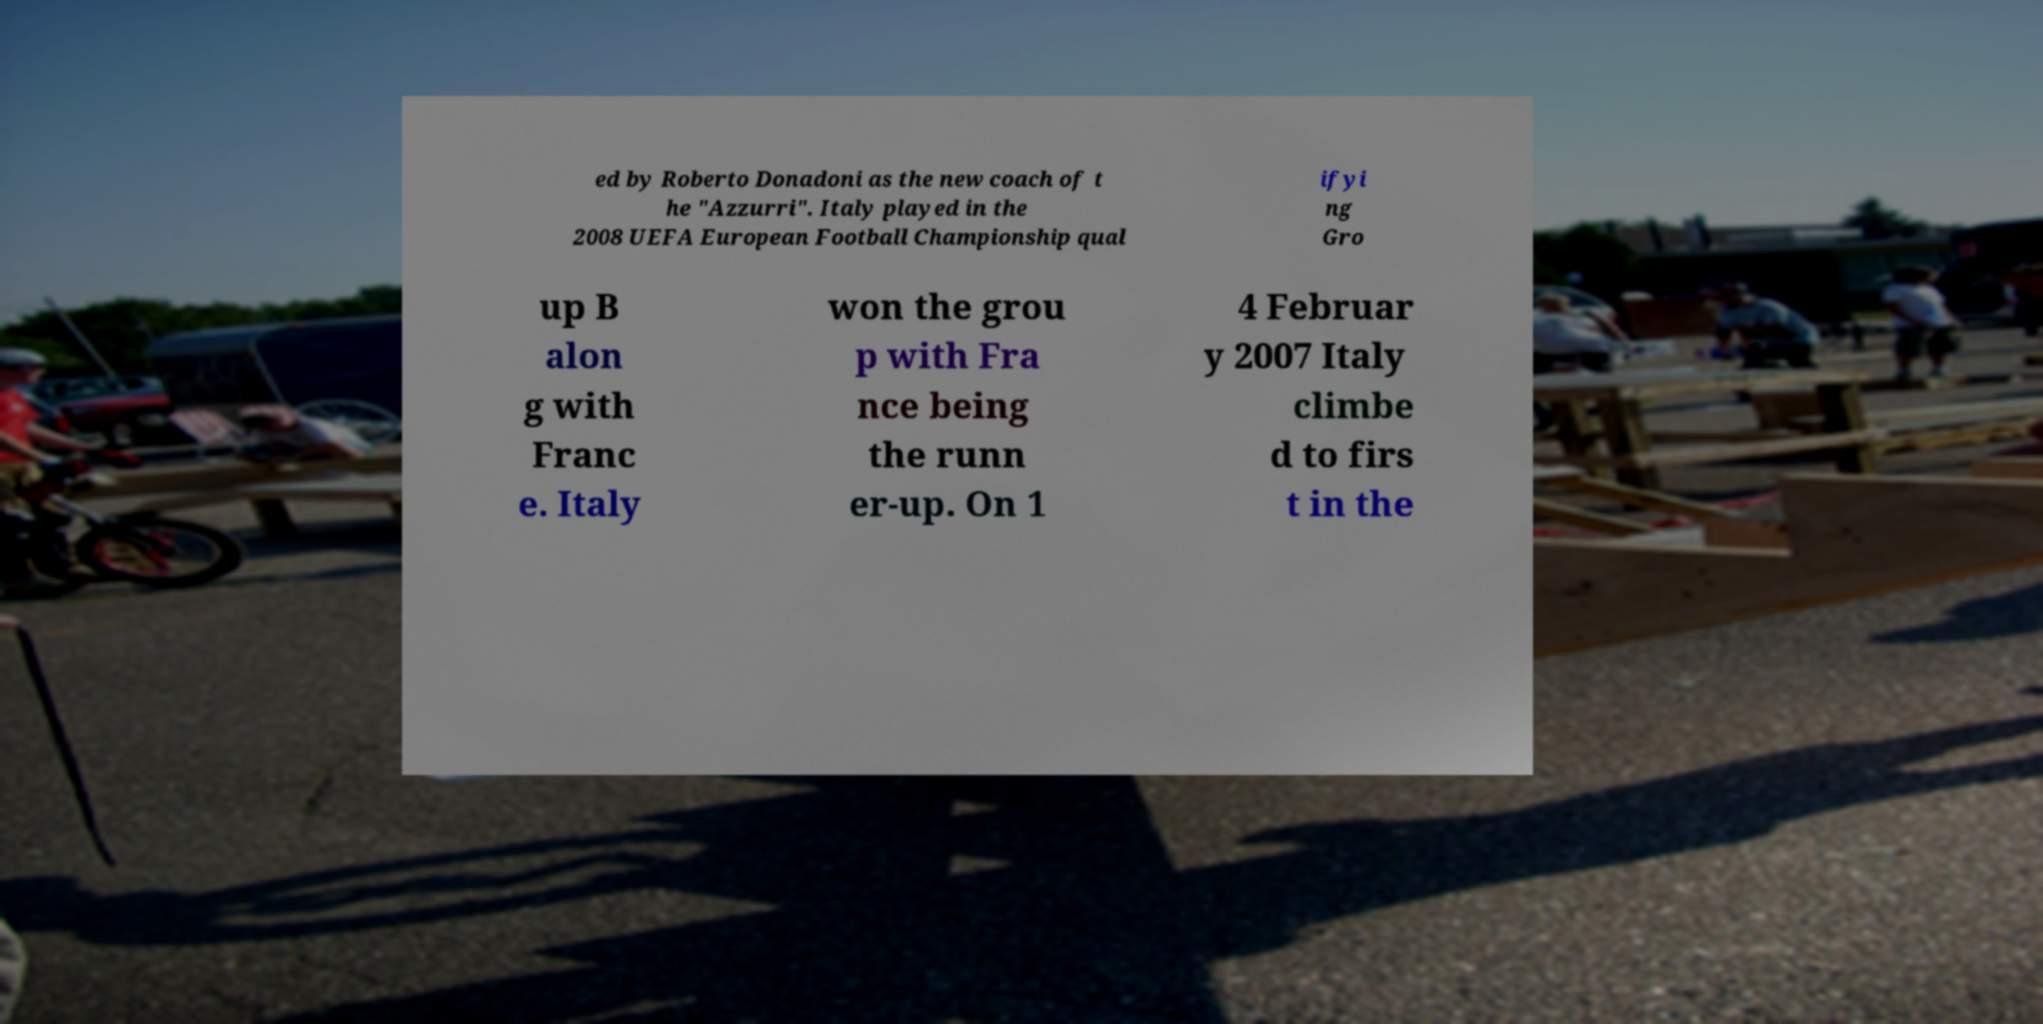Can you read and provide the text displayed in the image?This photo seems to have some interesting text. Can you extract and type it out for me? ed by Roberto Donadoni as the new coach of t he "Azzurri". Italy played in the 2008 UEFA European Football Championship qual ifyi ng Gro up B alon g with Franc e. Italy won the grou p with Fra nce being the runn er-up. On 1 4 Februar y 2007 Italy climbe d to firs t in the 